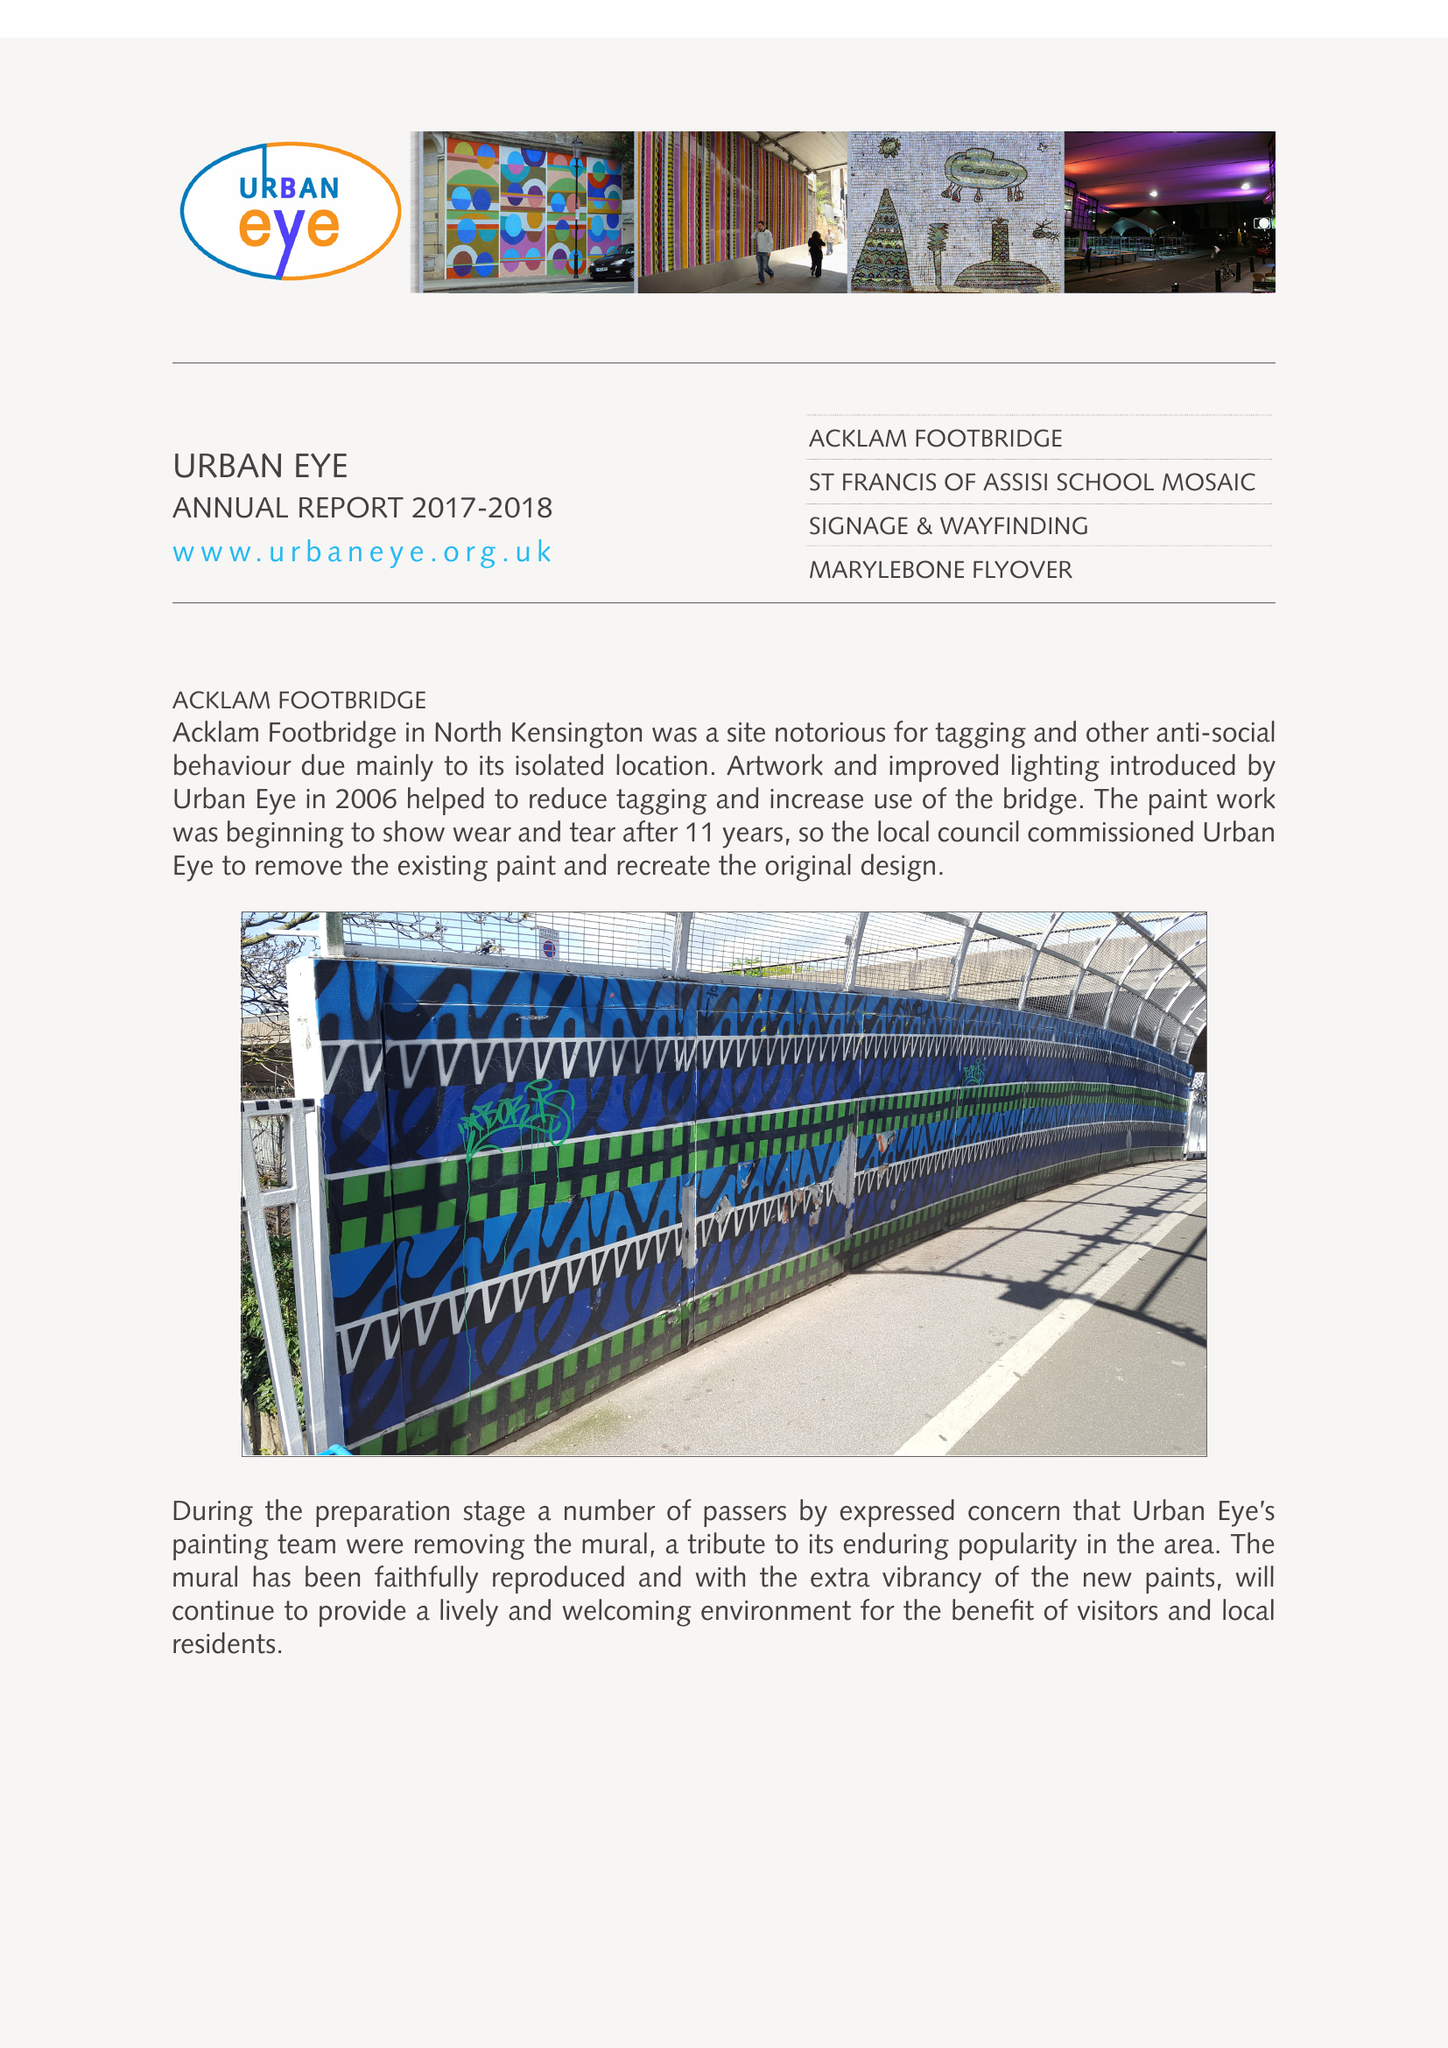What is the value for the spending_annually_in_british_pounds?
Answer the question using a single word or phrase. 28486.00 